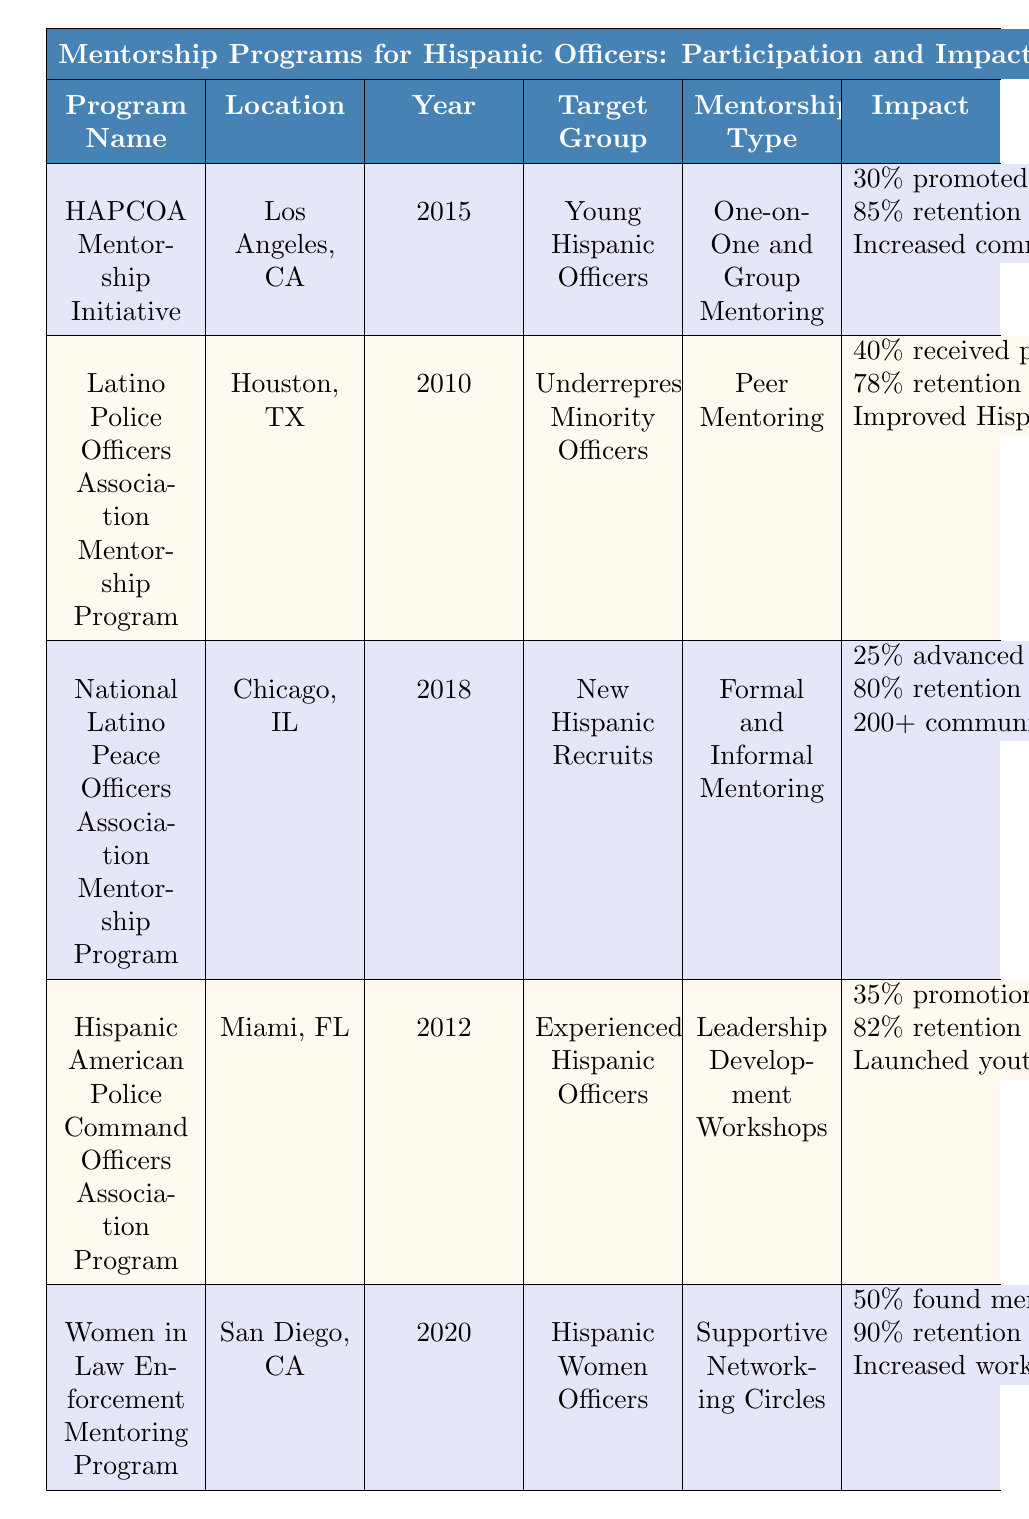What is the year of establishment for the HAPCOA Mentorship Initiative? The table lists the HAPCOA Mentorship Initiative under the "Program Details" section, where the "Year Established" field indicates it was established in 2015.
Answer: 2015 Which program has the highest participation rate? The participation rates for each program are listed in the table. Comparing them, the HAPCOA Mentorship Initiative has a participation rate of 75%, which is the highest among all listed programs.
Answer: HAPCOA Mentorship Initiative How many participants advanced to leadership roles in the National Latino Peace Officers Association Mentorship Program? The table shows that 25% of participants in the National Latino Peace Officers Association Mentorship Program advanced to leadership roles.
Answer: 25% What is the average retention rate of the programs listed? The retention rates provided are 85%, 78%, 80%, 82%, and 90%. Adding them (85 + 78 + 80 + 82 + 90) gives 415, and dividing by the number of programs (5) results in an average retention rate of 83%.
Answer: 83% Is there a program specifically targeting Hispanic women officers? The table indicates that the "Women in Law Enforcement Mentoring Program" targets Hispanic women officers, therefore, this statement is true.
Answer: Yes What impact does the Women in Law Enforcement Mentoring Program have on community engagement? The table specifies that this program has increased workshops for young women in the community as a form of community engagement.
Answer: Increased workshops for young women How does the career advancement impact of the Latino Police Officers Association Mentorship Program compare to the HAPCOA Mentorship Initiative? The table shows that 40% of participants from the Latino Police Officers Association Mentorship Program received promotions, while 30% of participants in the HAPCOA Mentorship Initiative were promoted within 2 years. Thus, the Latino program has a higher career advancement impact.
Answer: Latino Police Officers Association Mentorship Program What retention rate is reported for the Women in Law Enforcement Mentoring Program? The table directly lists the retention rate for the Women in Law Enforcement Mentoring Program as 90% after 3 years.
Answer: 90% Which program established in 2012 focuses on leadership development? Referring to the table, the "Hispanic American Police Command Officers Association Program," established in 2012, focuses on leadership development workshops.
Answer: Hispanic American Police Command Officers Association Program What is the total percentage of improvement in community engagement reported by the HAPCOA Mentorship Initiative and the Hispanic American Police Command Officers Association Program? The HAPCOA Mentorship Initiative reports increased involvement in local Hispanic communities, and the Hispanic American Police Command Officers Association Program launched youth mentorship in schools. Though these are qualitative impacts, both programs indicate positive community engagement. Thus, the impact cannot be quantitatively summed.
Answer: N/A Which program has a retention rate of 78% after five years? The table explicitly states that the Latino Police Officers Association Mentorship Program has a retention rate of 78% after five years.
Answer: Latino Police Officers Association Mentorship Program 